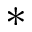Convert formula to latex. <formula><loc_0><loc_0><loc_500><loc_500>*</formula> 